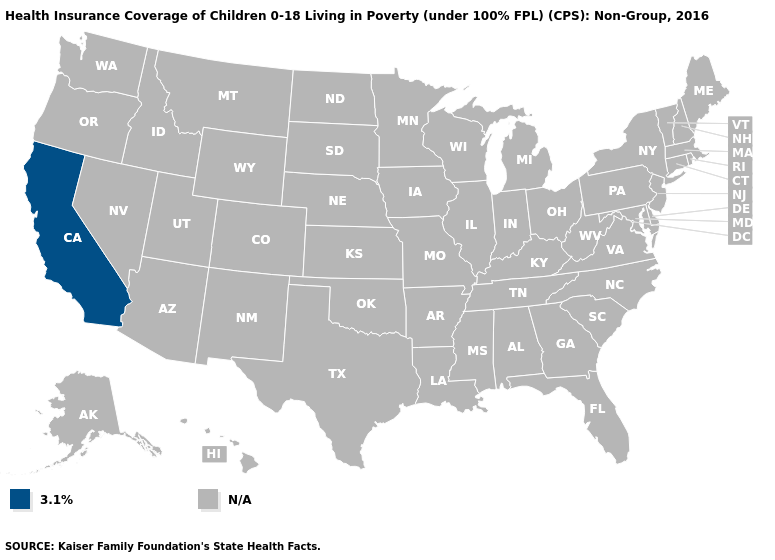Name the states that have a value in the range N/A?
Give a very brief answer. Alabama, Alaska, Arizona, Arkansas, Colorado, Connecticut, Delaware, Florida, Georgia, Hawaii, Idaho, Illinois, Indiana, Iowa, Kansas, Kentucky, Louisiana, Maine, Maryland, Massachusetts, Michigan, Minnesota, Mississippi, Missouri, Montana, Nebraska, Nevada, New Hampshire, New Jersey, New Mexico, New York, North Carolina, North Dakota, Ohio, Oklahoma, Oregon, Pennsylvania, Rhode Island, South Carolina, South Dakota, Tennessee, Texas, Utah, Vermont, Virginia, Washington, West Virginia, Wisconsin, Wyoming. Name the states that have a value in the range 3.1%?
Concise answer only. California. Name the states that have a value in the range N/A?
Answer briefly. Alabama, Alaska, Arizona, Arkansas, Colorado, Connecticut, Delaware, Florida, Georgia, Hawaii, Idaho, Illinois, Indiana, Iowa, Kansas, Kentucky, Louisiana, Maine, Maryland, Massachusetts, Michigan, Minnesota, Mississippi, Missouri, Montana, Nebraska, Nevada, New Hampshire, New Jersey, New Mexico, New York, North Carolina, North Dakota, Ohio, Oklahoma, Oregon, Pennsylvania, Rhode Island, South Carolina, South Dakota, Tennessee, Texas, Utah, Vermont, Virginia, Washington, West Virginia, Wisconsin, Wyoming. Does the first symbol in the legend represent the smallest category?
Give a very brief answer. Yes. What is the value of Florida?
Be succinct. N/A. What is the value of Florida?
Short answer required. N/A. What is the value of Ohio?
Keep it brief. N/A. Is the legend a continuous bar?
Give a very brief answer. No. Name the states that have a value in the range N/A?
Write a very short answer. Alabama, Alaska, Arizona, Arkansas, Colorado, Connecticut, Delaware, Florida, Georgia, Hawaii, Idaho, Illinois, Indiana, Iowa, Kansas, Kentucky, Louisiana, Maine, Maryland, Massachusetts, Michigan, Minnesota, Mississippi, Missouri, Montana, Nebraska, Nevada, New Hampshire, New Jersey, New Mexico, New York, North Carolina, North Dakota, Ohio, Oklahoma, Oregon, Pennsylvania, Rhode Island, South Carolina, South Dakota, Tennessee, Texas, Utah, Vermont, Virginia, Washington, West Virginia, Wisconsin, Wyoming. What is the value of Tennessee?
Answer briefly. N/A. What is the value of Nebraska?
Short answer required. N/A. 